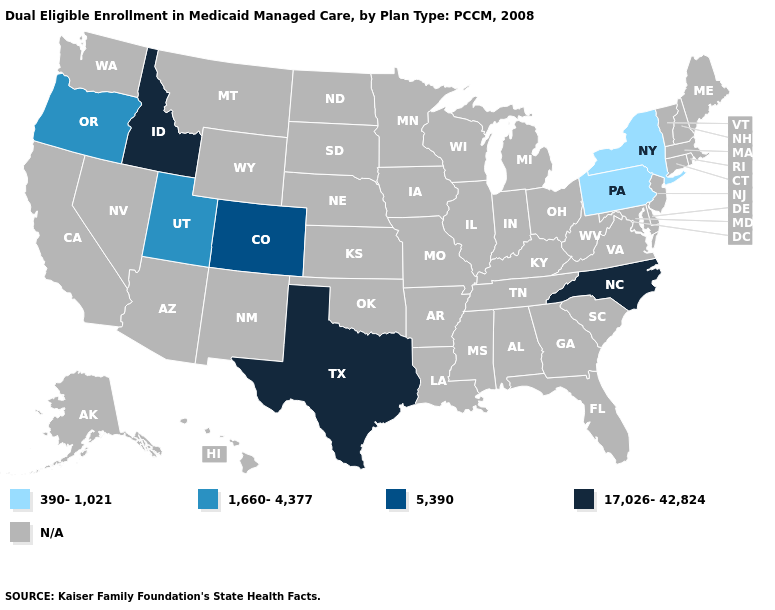What is the lowest value in the USA?
Be succinct. 390-1,021. What is the value of Arkansas?
Give a very brief answer. N/A. Does Pennsylvania have the lowest value in the USA?
Short answer required. Yes. What is the highest value in the Northeast ?
Keep it brief. 390-1,021. Name the states that have a value in the range 1,660-4,377?
Write a very short answer. Oregon, Utah. What is the value of Connecticut?
Write a very short answer. N/A. Does Texas have the lowest value in the USA?
Answer briefly. No. Which states have the lowest value in the South?
Quick response, please. North Carolina, Texas. What is the value of Arkansas?
Answer briefly. N/A. Name the states that have a value in the range 1,660-4,377?
Keep it brief. Oregon, Utah. 